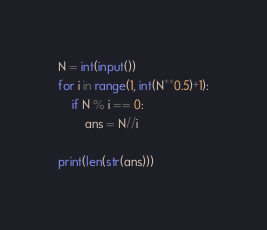Convert code to text. <code><loc_0><loc_0><loc_500><loc_500><_Python_>N = int(input())
for i in range(1, int(N**0.5)+1):
    if N % i == 0:
        ans = N//i
        
print(len(str(ans)))</code> 